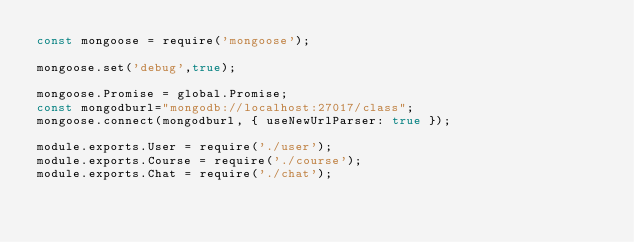Convert code to text. <code><loc_0><loc_0><loc_500><loc_500><_JavaScript_>const mongoose = require('mongoose');

mongoose.set('debug',true);

mongoose.Promise = global.Promise;
const mongodburl="mongodb://localhost:27017/class";
mongoose.connect(mongodburl, { useNewUrlParser: true });

module.exports.User = require('./user');
module.exports.Course = require('./course');
module.exports.Chat = require('./chat');</code> 